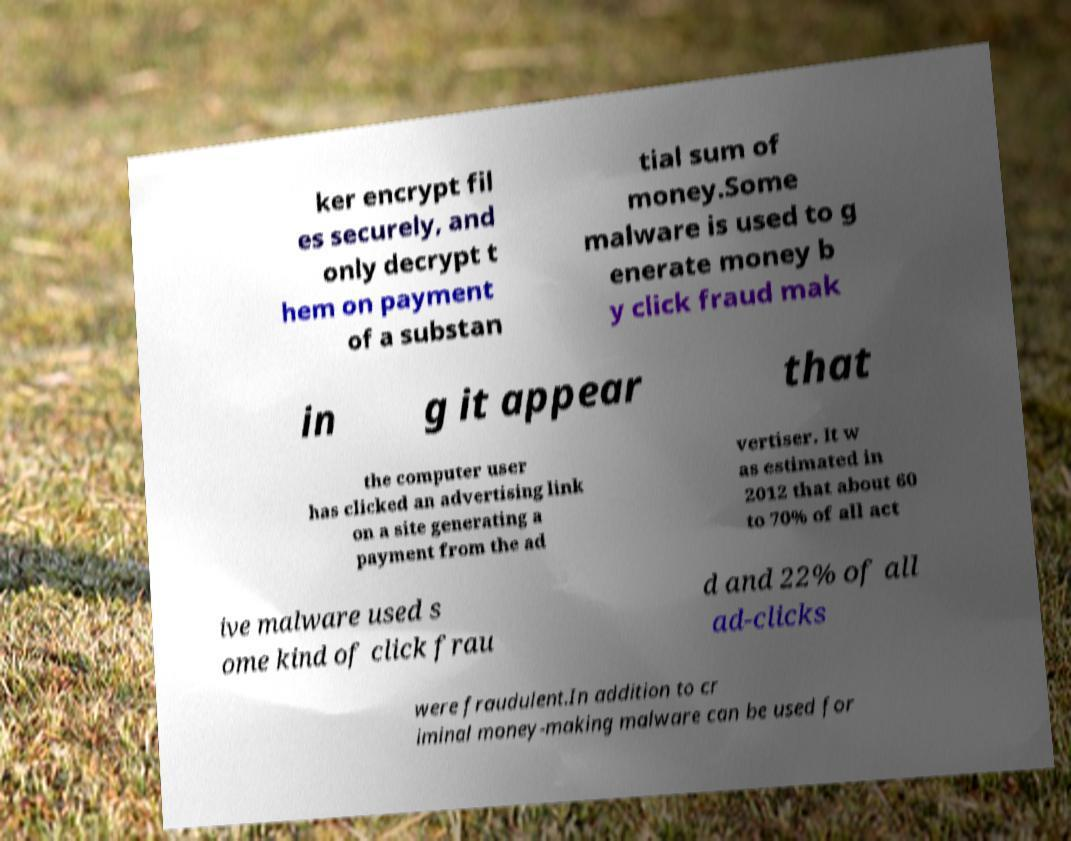Can you read and provide the text displayed in the image?This photo seems to have some interesting text. Can you extract and type it out for me? ker encrypt fil es securely, and only decrypt t hem on payment of a substan tial sum of money.Some malware is used to g enerate money b y click fraud mak in g it appear that the computer user has clicked an advertising link on a site generating a payment from the ad vertiser. It w as estimated in 2012 that about 60 to 70% of all act ive malware used s ome kind of click frau d and 22% of all ad-clicks were fraudulent.In addition to cr iminal money-making malware can be used for 